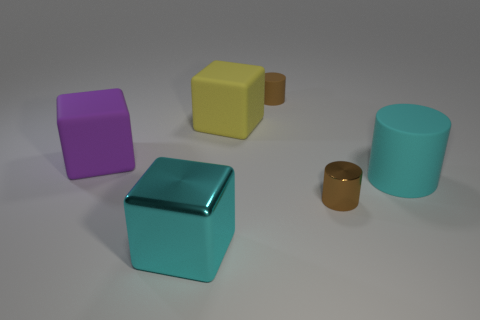Add 2 yellow things. How many objects exist? 8 Subtract 0 red cylinders. How many objects are left? 6 Subtract all purple cubes. Subtract all tiny metal cylinders. How many objects are left? 4 Add 1 big rubber blocks. How many big rubber blocks are left? 3 Add 3 small gray matte balls. How many small gray matte balls exist? 3 